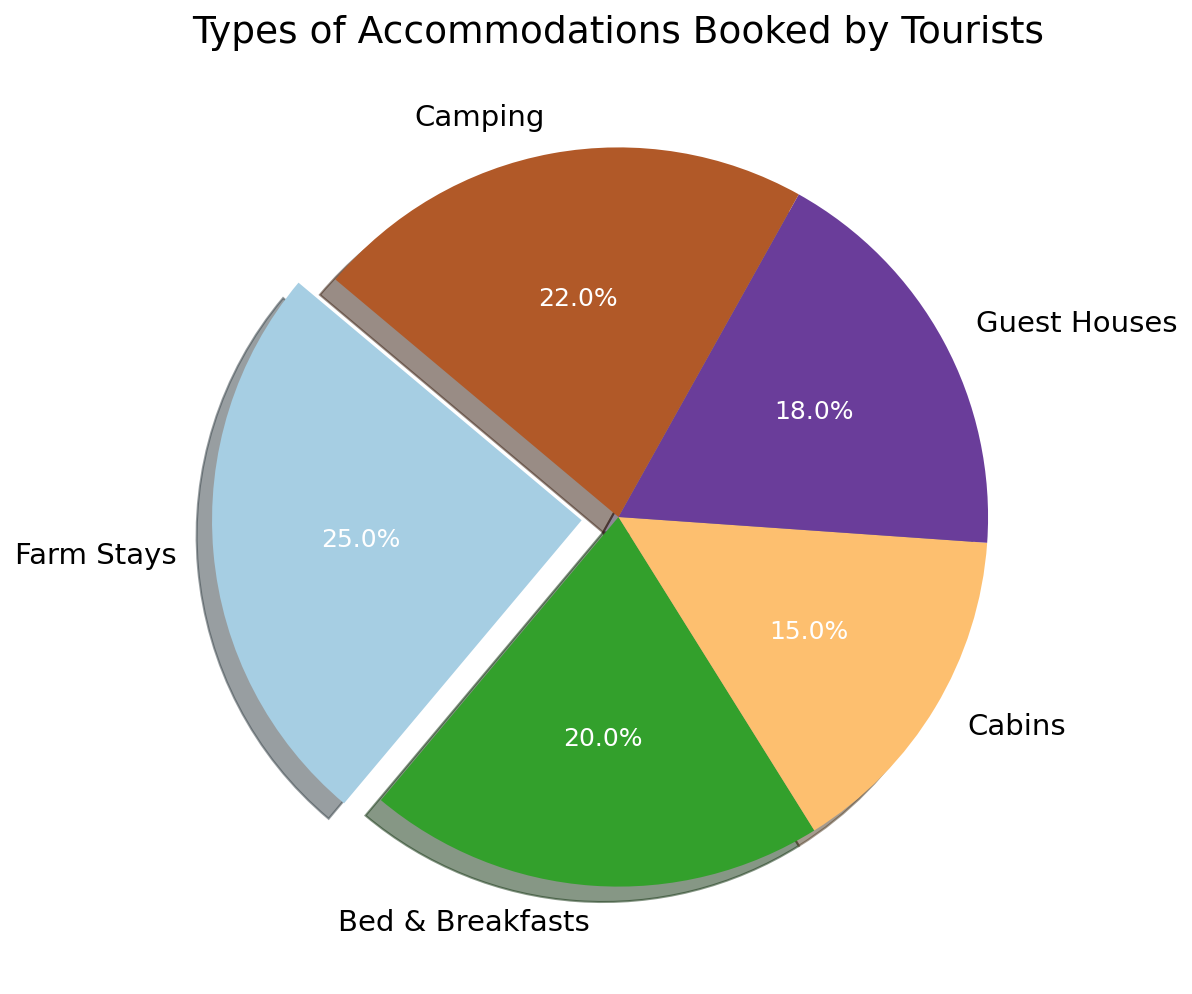Which type of accommodation is the most booked? By examining the pie chart, we see that the largest slice is for Farm Stays with 25%.
Answer: Farm Stays Which two types of accommodations have the closest booking percentages? By comparing the percentages, Guest Houses (18%) and Bed & Breakfasts (20%) have the closest booking percentages, with a difference of only 2%.
Answer: Guest Houses and Bed & Breakfasts What's the total percentage share of Cabins and Camping combined? Add the percentages for Cabins (15%) and Camping (22%). The total is 15% + 22% = 37%.
Answer: 37% What is the least booked type of accommodation? The smallest slice on the pie chart represents Cabins with 15%.
Answer: Cabins How much more popular are Farm Stays compared to Cabins? Subtract the percentage for Cabins (15%) from the percentage for Farm Stays (25%). The difference is 25% - 15% = 10%.
Answer: 10% Are Bed & Breakfasts booked more frequently than Camping? By checking the percentages, Bed & Breakfasts have 20%, and Camping has 22%, so Bed & Breakfasts are less frequently booked.
Answer: No What percentage difference is there between the most and least booked accommodations? The most booked is Farm Stays (25%) and the least is Cabins (15%). The difference is 25% - 15% = 10%.
Answer: 10% If you were to visually pick out the Farm Stays segment, what visual attribute distinguishes it? The Farm Stays segment is visually distinguished by being "exploded" out from the rest of the pie chart, making it stand out more.
Answer: Exploded segment Which accommodation type is represented by the slightly larger slice, Guest Houses or Bed & Breakfasts? By observing the slices, Bed & Breakfasts is slightly larger at 20% compared to Guest Houses at 18%.
Answer: Bed & Breakfasts What is the combined percentage of accommodations that include an experience with nature (Farm Stays and Camping)? Add the percentages for Farm Stays (25%) and Camping (22%). The total is 25% + 22% = 47%.
Answer: 47% 